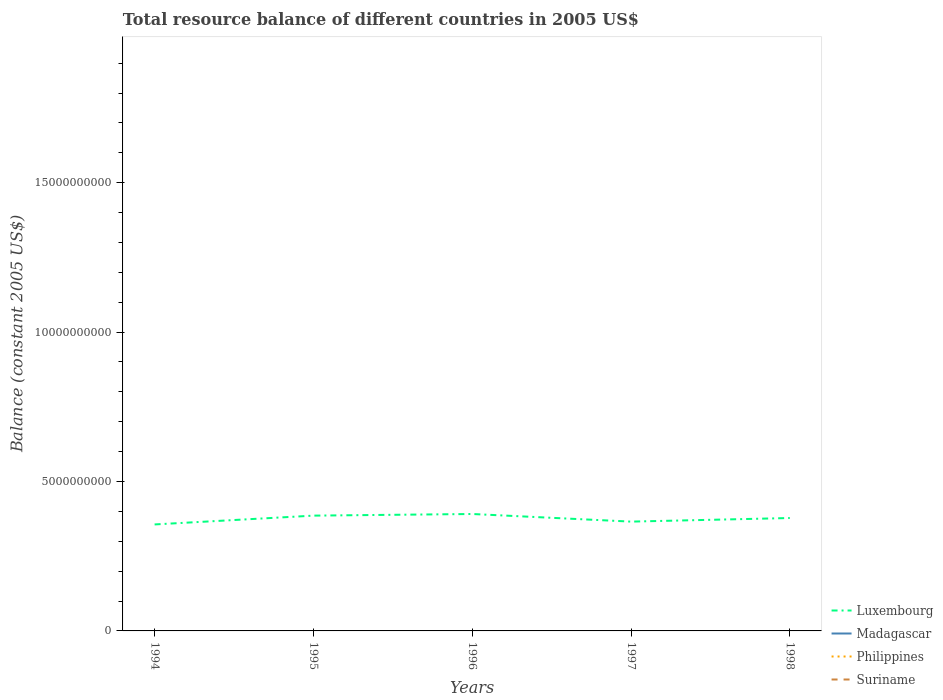How many different coloured lines are there?
Keep it short and to the point. 1. Across all years, what is the maximum total resource balance in Luxembourg?
Your answer should be very brief. 3.56e+09. What is the total total resource balance in Luxembourg in the graph?
Ensure brevity in your answer.  -9.45e+07. What is the difference between the highest and the second highest total resource balance in Luxembourg?
Offer a terse response. 3.49e+08. Is the total resource balance in Madagascar strictly greater than the total resource balance in Luxembourg over the years?
Keep it short and to the point. Yes. How many lines are there?
Keep it short and to the point. 1. How many years are there in the graph?
Offer a terse response. 5. What is the difference between two consecutive major ticks on the Y-axis?
Your answer should be compact. 5.00e+09. Does the graph contain any zero values?
Offer a very short reply. Yes. How many legend labels are there?
Keep it short and to the point. 4. What is the title of the graph?
Keep it short and to the point. Total resource balance of different countries in 2005 US$. Does "San Marino" appear as one of the legend labels in the graph?
Provide a short and direct response. No. What is the label or title of the X-axis?
Your answer should be compact. Years. What is the label or title of the Y-axis?
Your answer should be very brief. Balance (constant 2005 US$). What is the Balance (constant 2005 US$) of Luxembourg in 1994?
Your answer should be compact. 3.56e+09. What is the Balance (constant 2005 US$) in Philippines in 1994?
Your response must be concise. 0. What is the Balance (constant 2005 US$) of Suriname in 1994?
Your response must be concise. 0. What is the Balance (constant 2005 US$) of Luxembourg in 1995?
Provide a succinct answer. 3.86e+09. What is the Balance (constant 2005 US$) in Suriname in 1995?
Provide a short and direct response. 0. What is the Balance (constant 2005 US$) in Luxembourg in 1996?
Provide a short and direct response. 3.91e+09. What is the Balance (constant 2005 US$) of Suriname in 1996?
Keep it short and to the point. 0. What is the Balance (constant 2005 US$) of Luxembourg in 1997?
Your response must be concise. 3.66e+09. What is the Balance (constant 2005 US$) in Madagascar in 1997?
Provide a succinct answer. 0. What is the Balance (constant 2005 US$) of Philippines in 1997?
Provide a succinct answer. 0. What is the Balance (constant 2005 US$) in Luxembourg in 1998?
Keep it short and to the point. 3.78e+09. What is the Balance (constant 2005 US$) of Suriname in 1998?
Your response must be concise. 0. Across all years, what is the maximum Balance (constant 2005 US$) in Luxembourg?
Ensure brevity in your answer.  3.91e+09. Across all years, what is the minimum Balance (constant 2005 US$) of Luxembourg?
Give a very brief answer. 3.56e+09. What is the total Balance (constant 2005 US$) of Luxembourg in the graph?
Your answer should be very brief. 1.88e+1. What is the total Balance (constant 2005 US$) of Madagascar in the graph?
Provide a short and direct response. 0. What is the difference between the Balance (constant 2005 US$) in Luxembourg in 1994 and that in 1995?
Ensure brevity in your answer.  -2.95e+08. What is the difference between the Balance (constant 2005 US$) of Luxembourg in 1994 and that in 1996?
Provide a short and direct response. -3.49e+08. What is the difference between the Balance (constant 2005 US$) in Luxembourg in 1994 and that in 1997?
Your answer should be very brief. -9.45e+07. What is the difference between the Balance (constant 2005 US$) in Luxembourg in 1994 and that in 1998?
Offer a very short reply. -2.15e+08. What is the difference between the Balance (constant 2005 US$) in Luxembourg in 1995 and that in 1996?
Your response must be concise. -5.46e+07. What is the difference between the Balance (constant 2005 US$) of Luxembourg in 1995 and that in 1997?
Make the answer very short. 2.00e+08. What is the difference between the Balance (constant 2005 US$) of Luxembourg in 1995 and that in 1998?
Offer a terse response. 8.00e+07. What is the difference between the Balance (constant 2005 US$) in Luxembourg in 1996 and that in 1997?
Make the answer very short. 2.55e+08. What is the difference between the Balance (constant 2005 US$) of Luxembourg in 1996 and that in 1998?
Provide a succinct answer. 1.35e+08. What is the difference between the Balance (constant 2005 US$) in Luxembourg in 1997 and that in 1998?
Provide a short and direct response. -1.20e+08. What is the average Balance (constant 2005 US$) of Luxembourg per year?
Provide a succinct answer. 3.75e+09. What is the average Balance (constant 2005 US$) in Madagascar per year?
Provide a succinct answer. 0. What is the average Balance (constant 2005 US$) of Philippines per year?
Provide a succinct answer. 0. What is the ratio of the Balance (constant 2005 US$) in Luxembourg in 1994 to that in 1995?
Ensure brevity in your answer.  0.92. What is the ratio of the Balance (constant 2005 US$) in Luxembourg in 1994 to that in 1996?
Your answer should be compact. 0.91. What is the ratio of the Balance (constant 2005 US$) in Luxembourg in 1994 to that in 1997?
Provide a short and direct response. 0.97. What is the ratio of the Balance (constant 2005 US$) in Luxembourg in 1994 to that in 1998?
Offer a terse response. 0.94. What is the ratio of the Balance (constant 2005 US$) of Luxembourg in 1995 to that in 1996?
Make the answer very short. 0.99. What is the ratio of the Balance (constant 2005 US$) of Luxembourg in 1995 to that in 1997?
Ensure brevity in your answer.  1.05. What is the ratio of the Balance (constant 2005 US$) of Luxembourg in 1995 to that in 1998?
Keep it short and to the point. 1.02. What is the ratio of the Balance (constant 2005 US$) in Luxembourg in 1996 to that in 1997?
Provide a succinct answer. 1.07. What is the ratio of the Balance (constant 2005 US$) of Luxembourg in 1996 to that in 1998?
Provide a short and direct response. 1.04. What is the ratio of the Balance (constant 2005 US$) of Luxembourg in 1997 to that in 1998?
Ensure brevity in your answer.  0.97. What is the difference between the highest and the second highest Balance (constant 2005 US$) in Luxembourg?
Make the answer very short. 5.46e+07. What is the difference between the highest and the lowest Balance (constant 2005 US$) of Luxembourg?
Keep it short and to the point. 3.49e+08. 